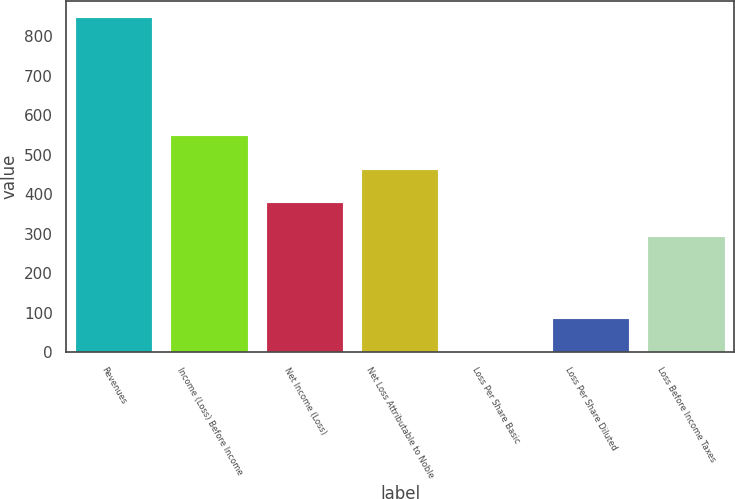<chart> <loc_0><loc_0><loc_500><loc_500><bar_chart><fcel>Revenues<fcel>Income (Loss) Before Income<fcel>Net Income (Loss)<fcel>Net Loss Attributable to Noble<fcel>Loss Per Share Basic<fcel>Loss Per Share Diluted<fcel>Loss Before Income Taxes<nl><fcel>847<fcel>546.89<fcel>377.63<fcel>462.26<fcel>0.73<fcel>85.36<fcel>293<nl></chart> 